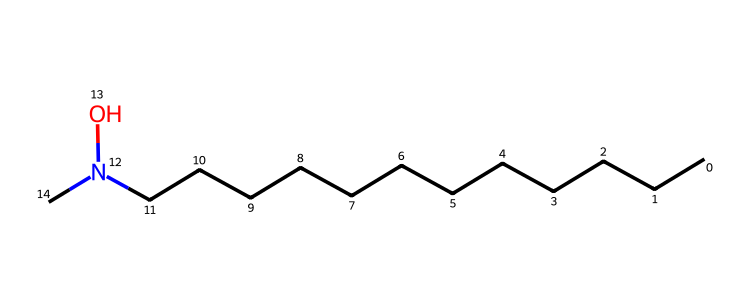What is the total number of carbon atoms in lauramine oxide? In the provided SMILES representation, "CCCCCCCCCCCCN(O)C", the sequence "CCCCCCCCCCCC" indicates a straight-chain structure with 12 carbon atoms. Additionally, there is one more carbon connected to the nitrogen, making a total of 13 carbon atoms.
Answer: 13 How many nitrogen atoms are present in lauramine oxide? The SMILES representation shows "N(O)", indicating the presence of a single nitrogen atom connected to the carbon chain.
Answer: 1 What type of chemical is lauramine oxide? Lauramine oxide is classified as a surfactant, specifically a mild surfactant, due to its structure containing a long hydrophobic carbon chain and a hydrophilic nitrogen functional group.
Answer: surfactant What functional groups are present in lauramine oxide? The SMILES notation "N(O)" in lauramine oxide indicates the presence of a hydroxyl group (associated with oxygen) and a quaternary nitrogen atom, which makes it an amine oxide.
Answer: amine oxide How many oxygen atoms are in lauramine oxide? In the SMILES representation "N(O)", there is one "O" directly indicated after the nitrogen, signifying a single oxygen atom in the structure.
Answer: 1 What molecular feature contributes to lauramine oxide being a mild surfactant? The combination of a long hydrophobic carbon chain and a functional nitrogen atom with an oxygen attached gives lauramine oxide its amphiphilic nature, allowing it to effectively reduce surface tension in solutions, qualifying it as a mild surfactant.
Answer: amphiphilic nature Which part of the molecule is hydrophobic? The long carbon chain (CCCCCCCCCCCC) is hydrophobic because it consists of only carbon and hydrogen atoms which do not interact favorably with water, making it the non-polar tail of the surfactant.
Answer: carbon chain 